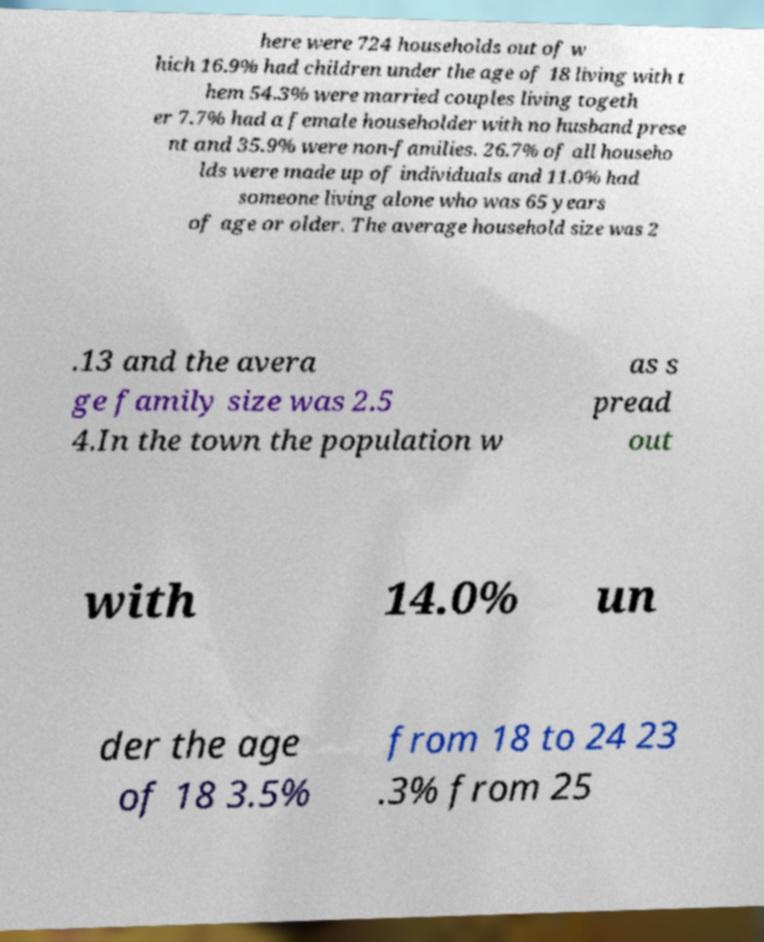Please read and relay the text visible in this image. What does it say? here were 724 households out of w hich 16.9% had children under the age of 18 living with t hem 54.3% were married couples living togeth er 7.7% had a female householder with no husband prese nt and 35.9% were non-families. 26.7% of all househo lds were made up of individuals and 11.0% had someone living alone who was 65 years of age or older. The average household size was 2 .13 and the avera ge family size was 2.5 4.In the town the population w as s pread out with 14.0% un der the age of 18 3.5% from 18 to 24 23 .3% from 25 